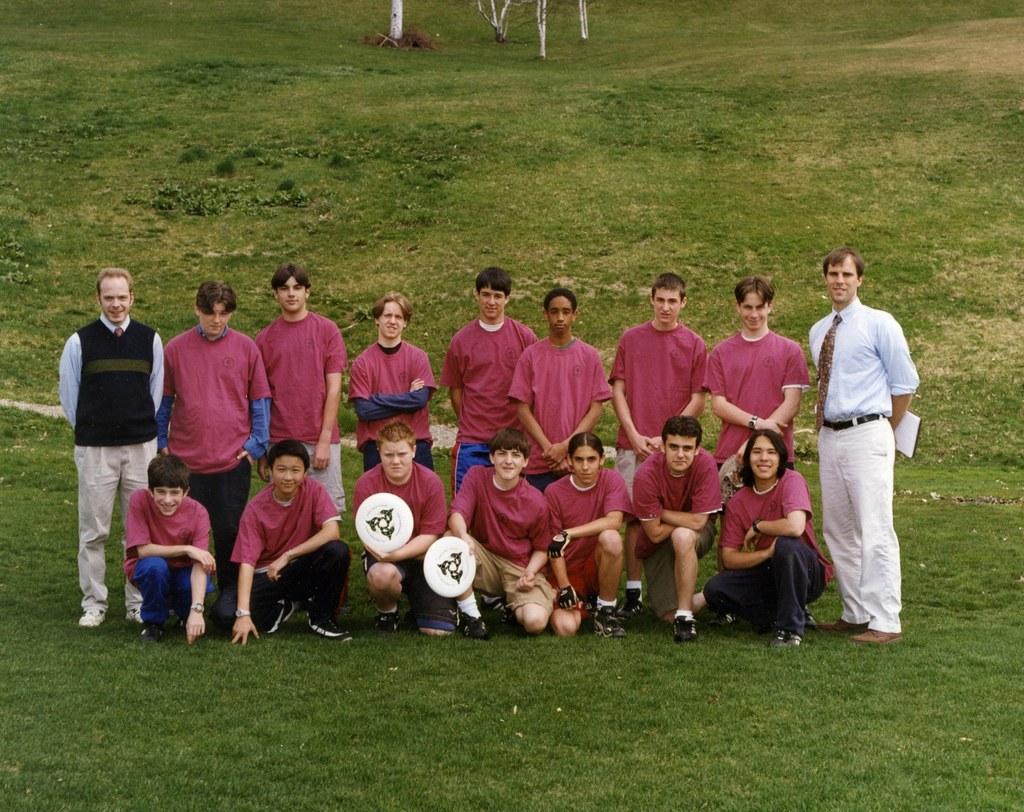In one or two sentences, can you explain what this image depicts? In this image we can see a few people, two of them are holding objects, another person is holding papers, there are plants, and the grass. 